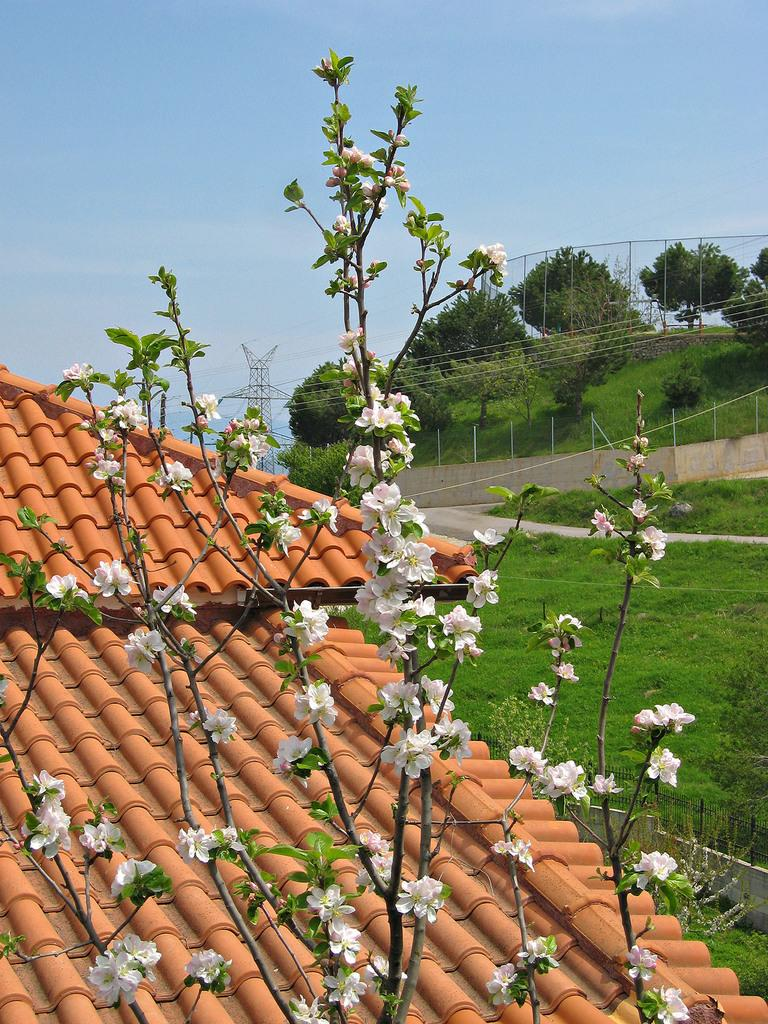What type of vegetation can be seen on the trees in the image? There are flowers on the trees in the image. What type of infrastructure is present in the image? Electric towers and electric cables are present in the image. What type of building can be seen in the image? There is a house in the image. What type of barrier is present in the image? There is a fence in the image. What part of the natural environment is visible in the image? The ground is visible in the image. What part of the sky is visible in the image? The sky is visible in the background of the image. How many apples are hanging from the electric towers in the image? There are no apples present in the image; it features flowers on trees, electric towers, electric cables, a house, a fence, the ground, and the sky. What type of exercise is the person in the image performing? There is no person present in the image, so it is not possible to determine what type of exercise they might be performing. 